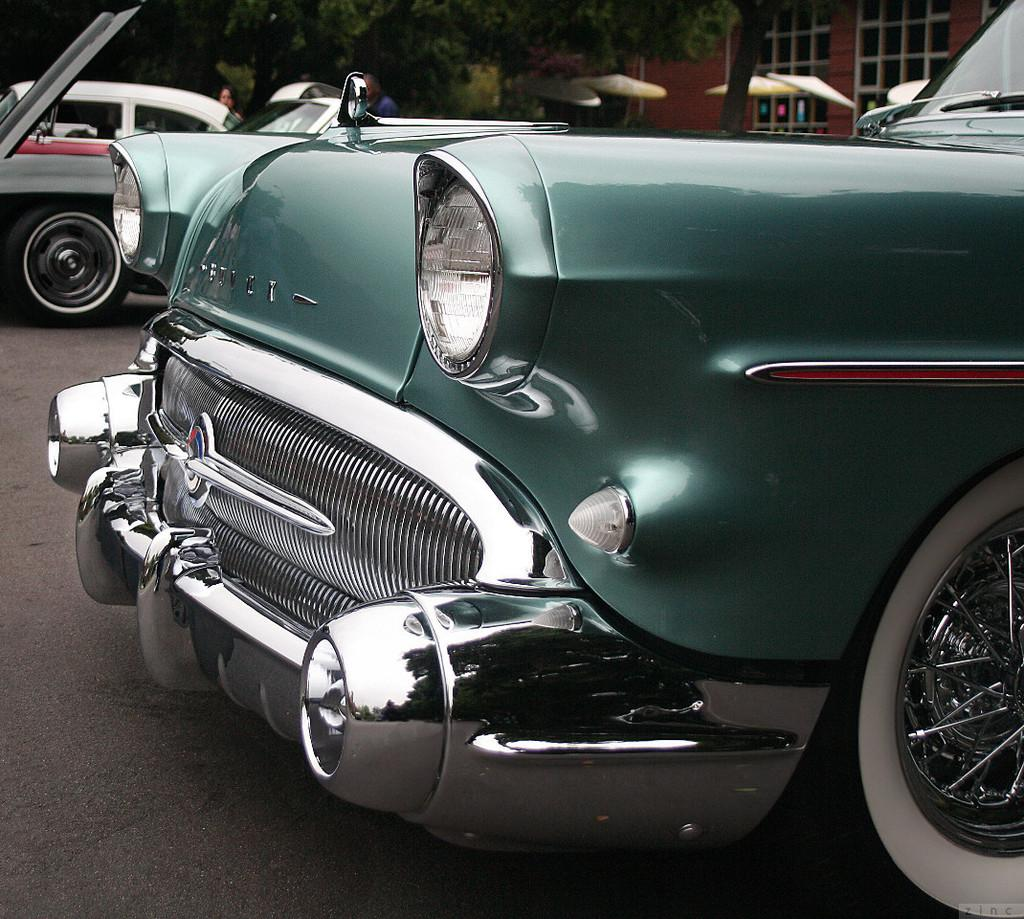What is the focus of the image? The image is a zoomed in view. What can be seen in the foreground of the image? There are cars parked in the foreground of the image. Where are the cars located? The cars are on the ground. What can be seen in the background of the image? There are trees and the windows of a house visible in the background of the image. What type of chalk is being used to draw on the cars in the image? There is no chalk or drawing present on the cars in the image. Can you see a jar of pickles on the windowsill of the house in the background? There is no jar of pickles or any other objects visible on the windowsill of the house in the image. 